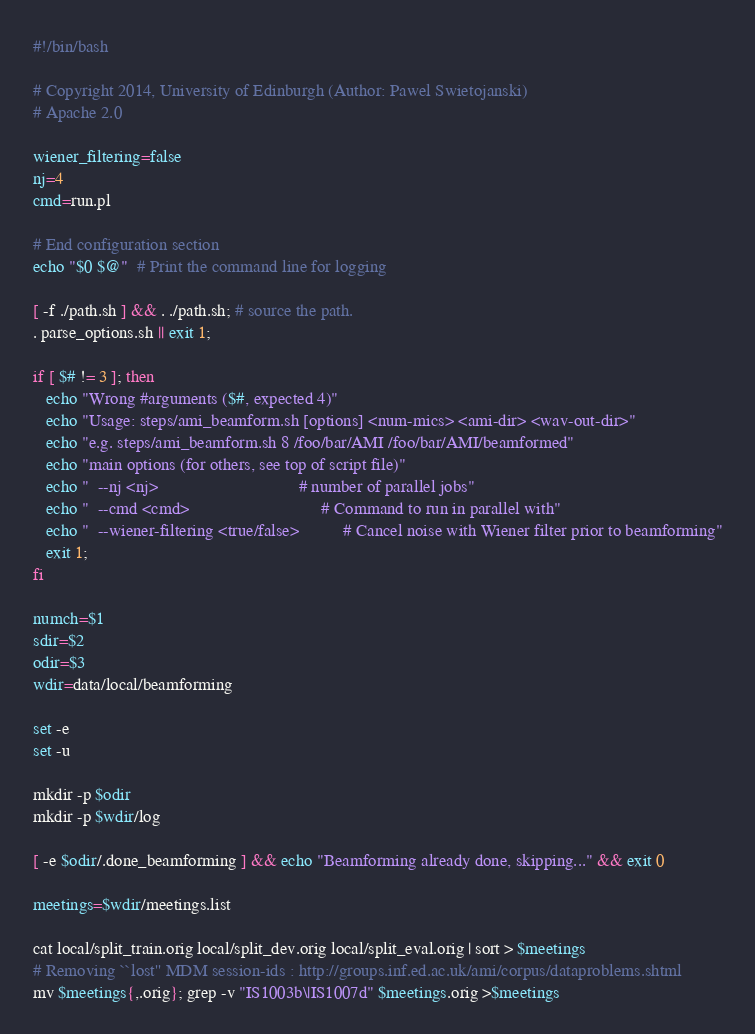Convert code to text. <code><loc_0><loc_0><loc_500><loc_500><_Bash_>#!/bin/bash

# Copyright 2014, University of Edinburgh (Author: Pawel Swietojanski)
# Apache 2.0

wiener_filtering=false
nj=4
cmd=run.pl

# End configuration section
echo "$0 $@"  # Print the command line for logging

[ -f ./path.sh ] && . ./path.sh; # source the path.
. parse_options.sh || exit 1;

if [ $# != 3 ]; then
   echo "Wrong #arguments ($#, expected 4)"
   echo "Usage: steps/ami_beamform.sh [options] <num-mics> <ami-dir> <wav-out-dir>"
   echo "e.g. steps/ami_beamform.sh 8 /foo/bar/AMI /foo/bar/AMI/beamformed"
   echo "main options (for others, see top of script file)"
   echo "  --nj <nj>                                # number of parallel jobs"
   echo "  --cmd <cmd>                              # Command to run in parallel with"
   echo "  --wiener-filtering <true/false>          # Cancel noise with Wiener filter prior to beamforming"
   exit 1;
fi

numch=$1
sdir=$2
odir=$3
wdir=data/local/beamforming

set -e
set -u

mkdir -p $odir
mkdir -p $wdir/log

[ -e $odir/.done_beamforming ] && echo "Beamforming already done, skipping..." && exit 0

meetings=$wdir/meetings.list

cat local/split_train.orig local/split_dev.orig local/split_eval.orig | sort > $meetings
# Removing ``lost'' MDM session-ids : http://groups.inf.ed.ac.uk/ami/corpus/dataproblems.shtml
mv $meetings{,.orig}; grep -v "IS1003b\|IS1007d" $meetings.orig >$meetings
</code> 